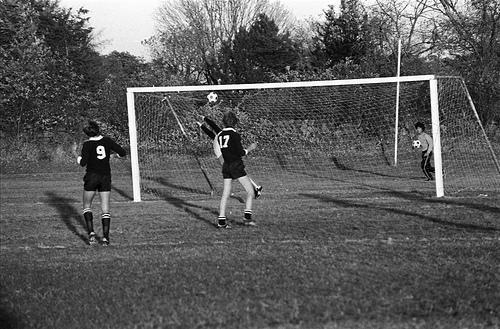How many people are playing tennis?
Give a very brief answer. 0. 